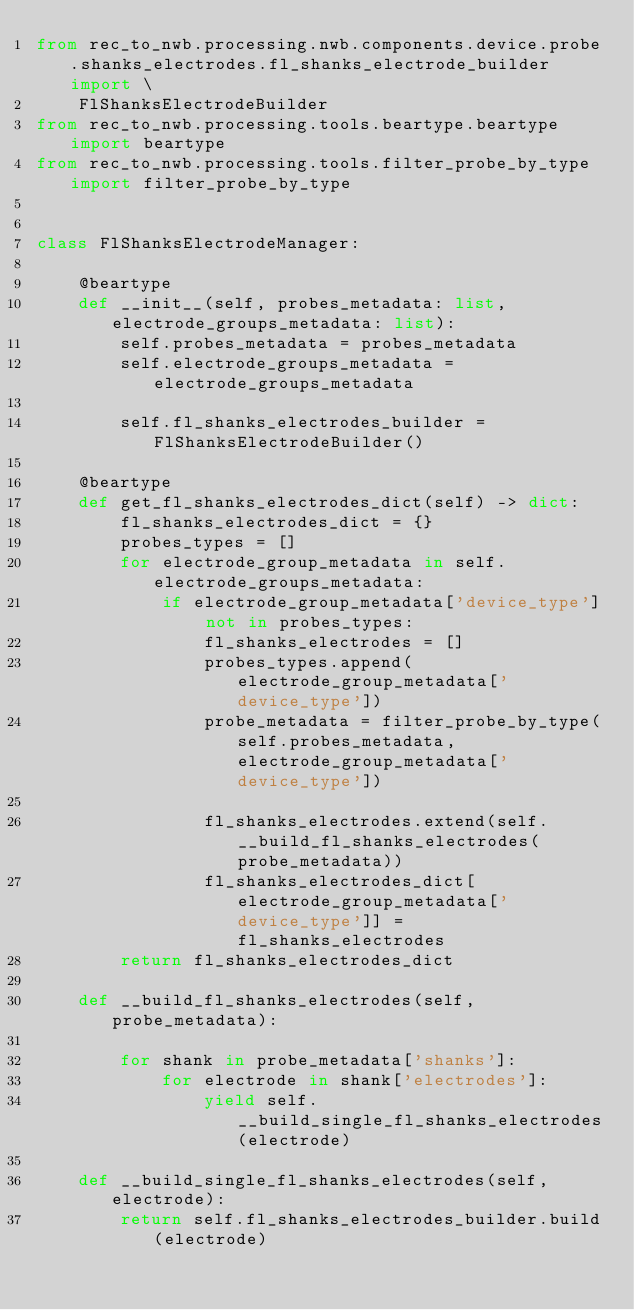Convert code to text. <code><loc_0><loc_0><loc_500><loc_500><_Python_>from rec_to_nwb.processing.nwb.components.device.probe.shanks_electrodes.fl_shanks_electrode_builder import \
    FlShanksElectrodeBuilder
from rec_to_nwb.processing.tools.beartype.beartype import beartype
from rec_to_nwb.processing.tools.filter_probe_by_type import filter_probe_by_type


class FlShanksElectrodeManager:

    @beartype
    def __init__(self, probes_metadata: list, electrode_groups_metadata: list):
        self.probes_metadata = probes_metadata
        self.electrode_groups_metadata = electrode_groups_metadata

        self.fl_shanks_electrodes_builder = FlShanksElectrodeBuilder()

    @beartype
    def get_fl_shanks_electrodes_dict(self) -> dict:
        fl_shanks_electrodes_dict = {}
        probes_types = []
        for electrode_group_metadata in self.electrode_groups_metadata:
            if electrode_group_metadata['device_type'] not in probes_types:
                fl_shanks_electrodes = []
                probes_types.append(electrode_group_metadata['device_type'])
                probe_metadata = filter_probe_by_type(self.probes_metadata, electrode_group_metadata['device_type'])

                fl_shanks_electrodes.extend(self.__build_fl_shanks_electrodes(probe_metadata))
                fl_shanks_electrodes_dict[electrode_group_metadata['device_type']] = fl_shanks_electrodes
        return fl_shanks_electrodes_dict

    def __build_fl_shanks_electrodes(self, probe_metadata):

        for shank in probe_metadata['shanks']:
            for electrode in shank['electrodes']:
                yield self.__build_single_fl_shanks_electrodes(electrode)

    def __build_single_fl_shanks_electrodes(self, electrode):
        return self.fl_shanks_electrodes_builder.build(electrode)</code> 